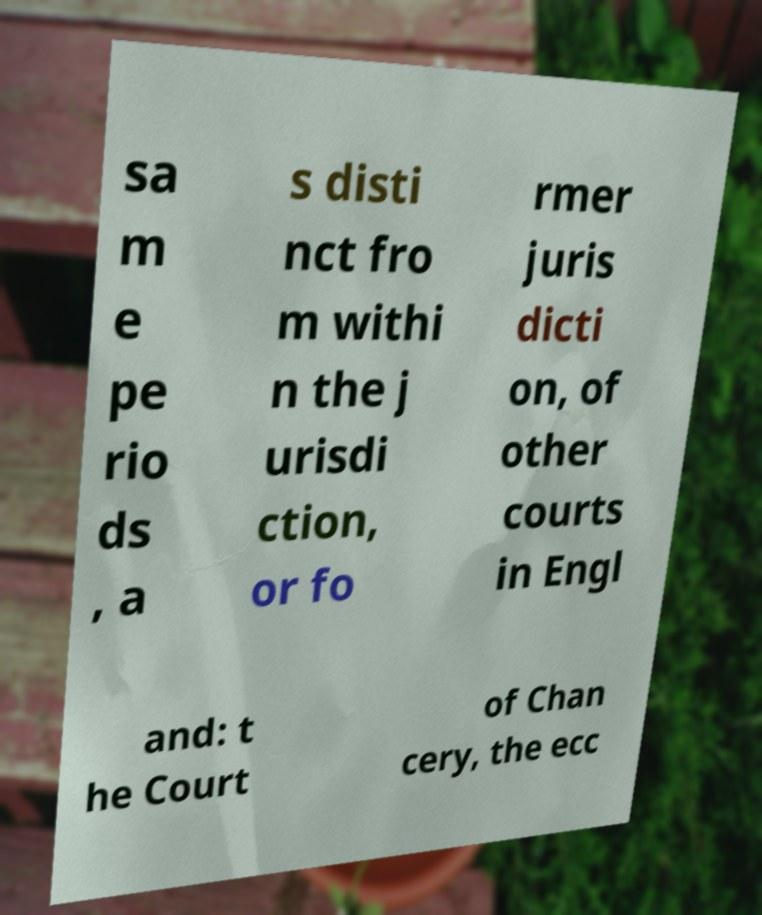Can you read and provide the text displayed in the image?This photo seems to have some interesting text. Can you extract and type it out for me? sa m e pe rio ds , a s disti nct fro m withi n the j urisdi ction, or fo rmer juris dicti on, of other courts in Engl and: t he Court of Chan cery, the ecc 